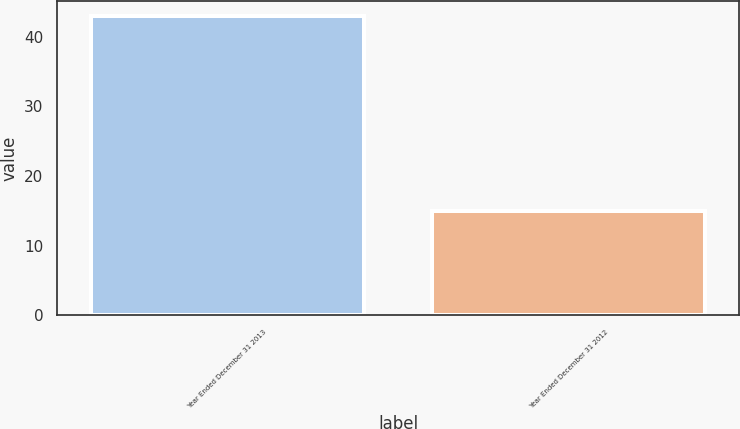Convert chart to OTSL. <chart><loc_0><loc_0><loc_500><loc_500><bar_chart><fcel>Year Ended December 31 2013<fcel>Year Ended December 31 2012<nl><fcel>43<fcel>15<nl></chart> 